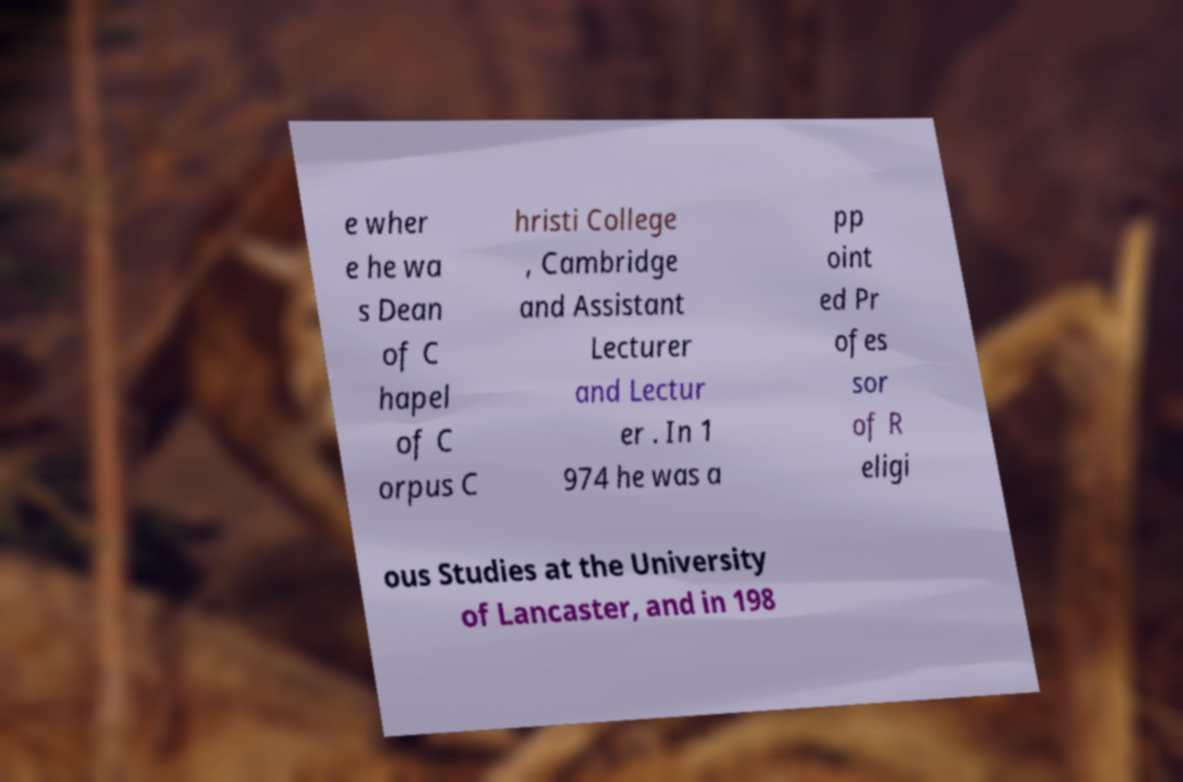I need the written content from this picture converted into text. Can you do that? e wher e he wa s Dean of C hapel of C orpus C hristi College , Cambridge and Assistant Lecturer and Lectur er . In 1 974 he was a pp oint ed Pr ofes sor of R eligi ous Studies at the University of Lancaster, and in 198 